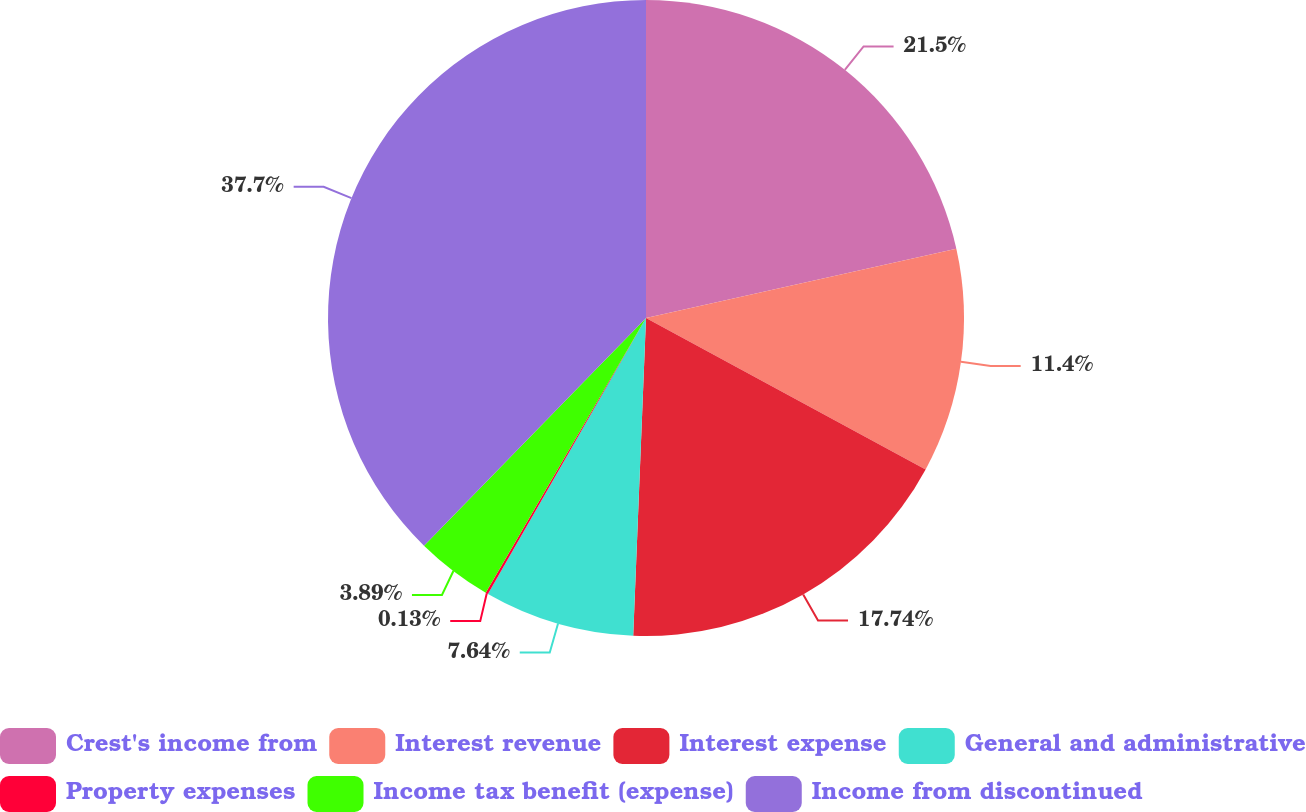<chart> <loc_0><loc_0><loc_500><loc_500><pie_chart><fcel>Crest's income from<fcel>Interest revenue<fcel>Interest expense<fcel>General and administrative<fcel>Property expenses<fcel>Income tax benefit (expense)<fcel>Income from discontinued<nl><fcel>21.5%<fcel>11.4%<fcel>17.74%<fcel>7.64%<fcel>0.13%<fcel>3.89%<fcel>37.7%<nl></chart> 